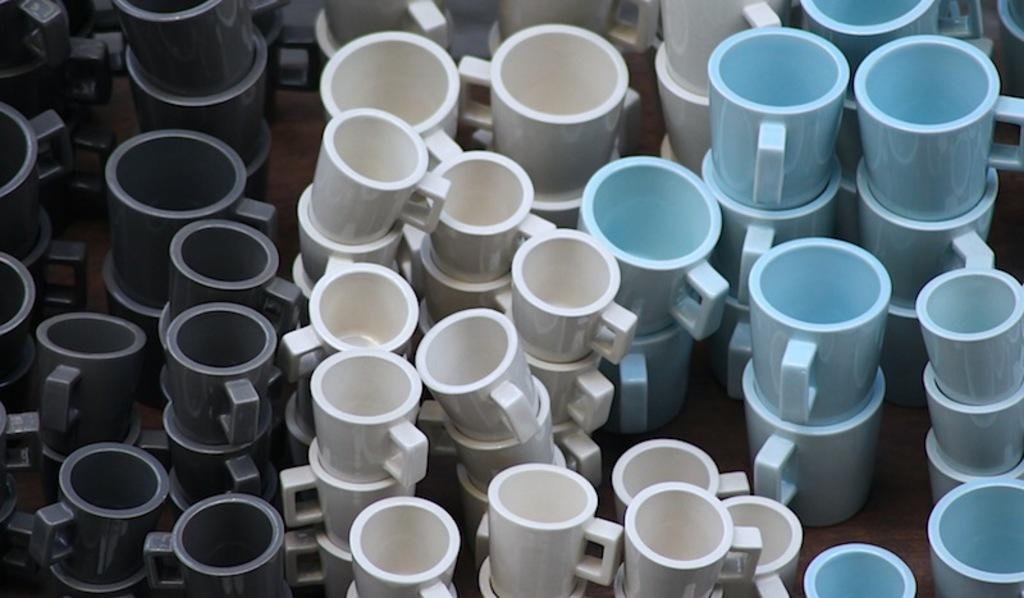What type of cups are in the picture? There are ceramic cups in the picture. What colors can be seen on the cups? The cups have black, white, and blue colors. What type of pizzas are being served on the ceramic cups in the image? There are no pizzas present in the image; it only features ceramic cups with black, white, and blue colors. 